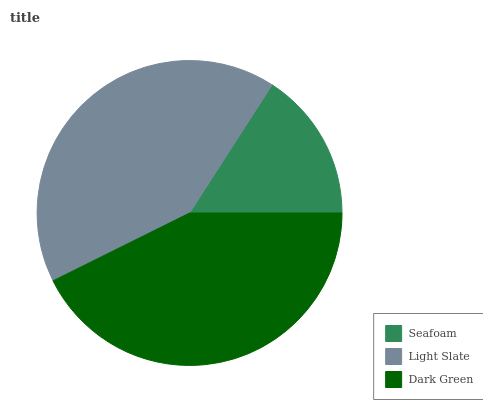Is Seafoam the minimum?
Answer yes or no. Yes. Is Dark Green the maximum?
Answer yes or no. Yes. Is Light Slate the minimum?
Answer yes or no. No. Is Light Slate the maximum?
Answer yes or no. No. Is Light Slate greater than Seafoam?
Answer yes or no. Yes. Is Seafoam less than Light Slate?
Answer yes or no. Yes. Is Seafoam greater than Light Slate?
Answer yes or no. No. Is Light Slate less than Seafoam?
Answer yes or no. No. Is Light Slate the high median?
Answer yes or no. Yes. Is Light Slate the low median?
Answer yes or no. Yes. Is Dark Green the high median?
Answer yes or no. No. Is Seafoam the low median?
Answer yes or no. No. 